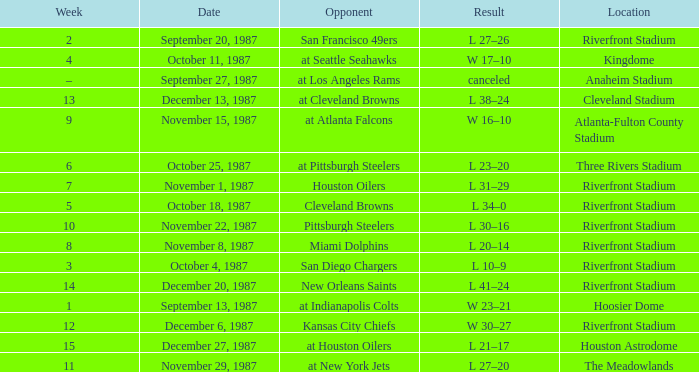What was the result of the game against the Miami Dolphins held at the Riverfront Stadium? L 20–14. 